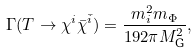<formula> <loc_0><loc_0><loc_500><loc_500>\Gamma ( T \rightarrow \chi ^ { i } \bar { \chi } ^ { \bar { i } } ) = \frac { m _ { i } ^ { 2 } m _ { \Phi } } { 1 9 2 \pi M _ { \text {G} } ^ { 2 } } ,</formula> 